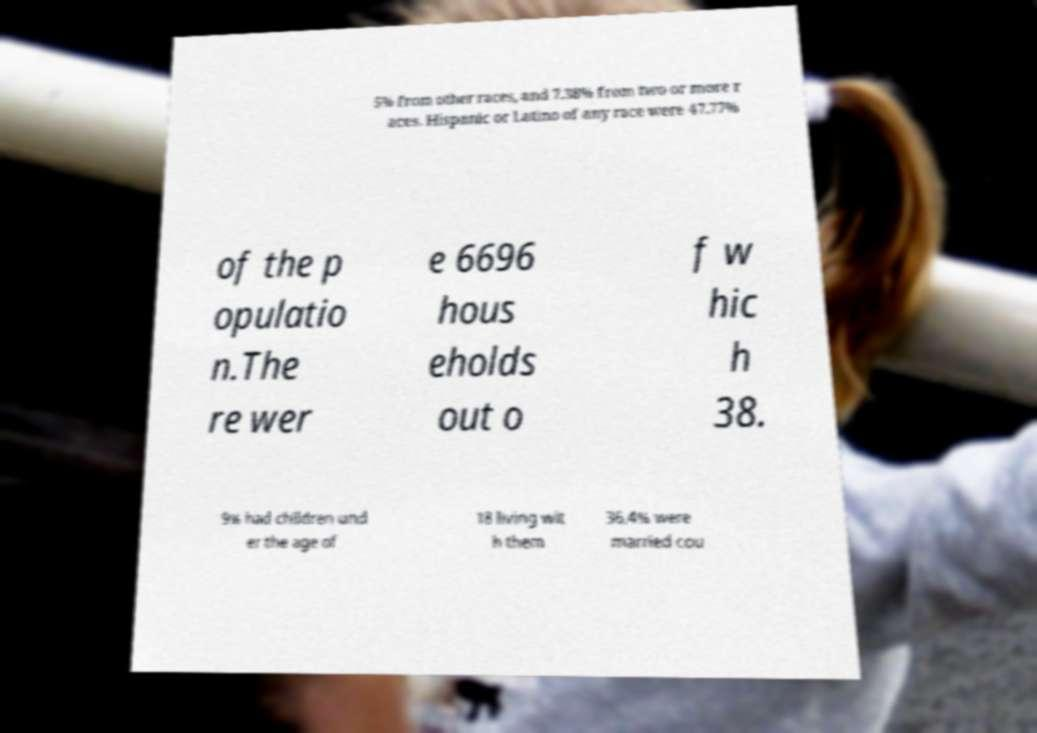For documentation purposes, I need the text within this image transcribed. Could you provide that? 5% from other races, and 7.38% from two or more r aces. Hispanic or Latino of any race were 47.77% of the p opulatio n.The re wer e 6696 hous eholds out o f w hic h 38. 9% had children und er the age of 18 living wit h them 36.4% were married cou 